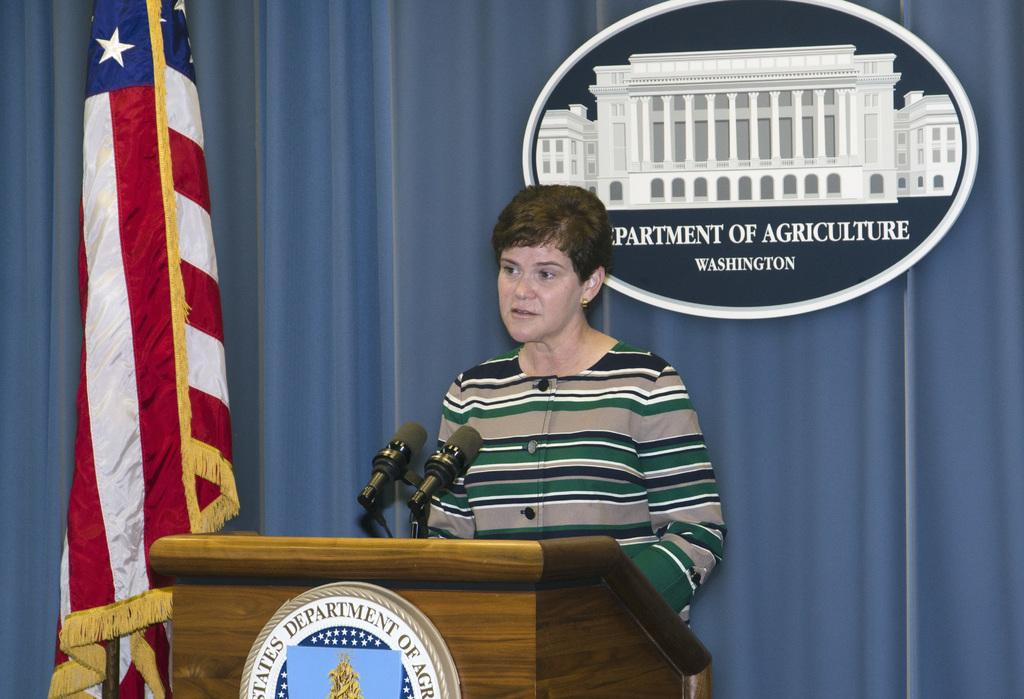What is the person in the image standing behind? The person is standing behind a brown-colored podium. What can be seen on the podium? There are two microphones on the podium. What is the color of the curtain in the image? The curtain in the image is blue. What is the purpose of the board in the image? The purpose of the board in the image is not specified, but it could be used for displaying information or writing notes. What direction is the bubble floating in the image? There is no bubble present in the image. 